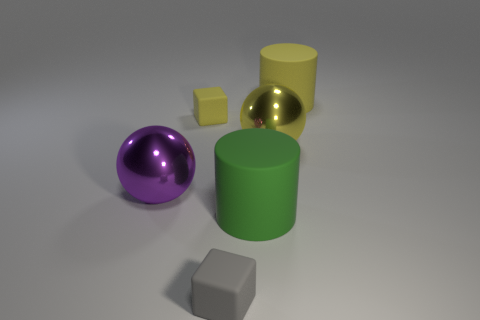Add 4 large shiny spheres. How many objects exist? 10 Subtract all yellow balls. How many balls are left? 1 Add 3 small yellow rubber things. How many small yellow rubber things are left? 4 Add 5 tiny gray rubber cubes. How many tiny gray rubber cubes exist? 6 Subtract 0 cyan balls. How many objects are left? 6 Subtract all balls. How many objects are left? 4 Subtract 2 blocks. How many blocks are left? 0 Subtract all red blocks. Subtract all cyan cylinders. How many blocks are left? 2 Subtract all gray cylinders. How many cyan spheres are left? 0 Subtract all big yellow cylinders. Subtract all large purple objects. How many objects are left? 4 